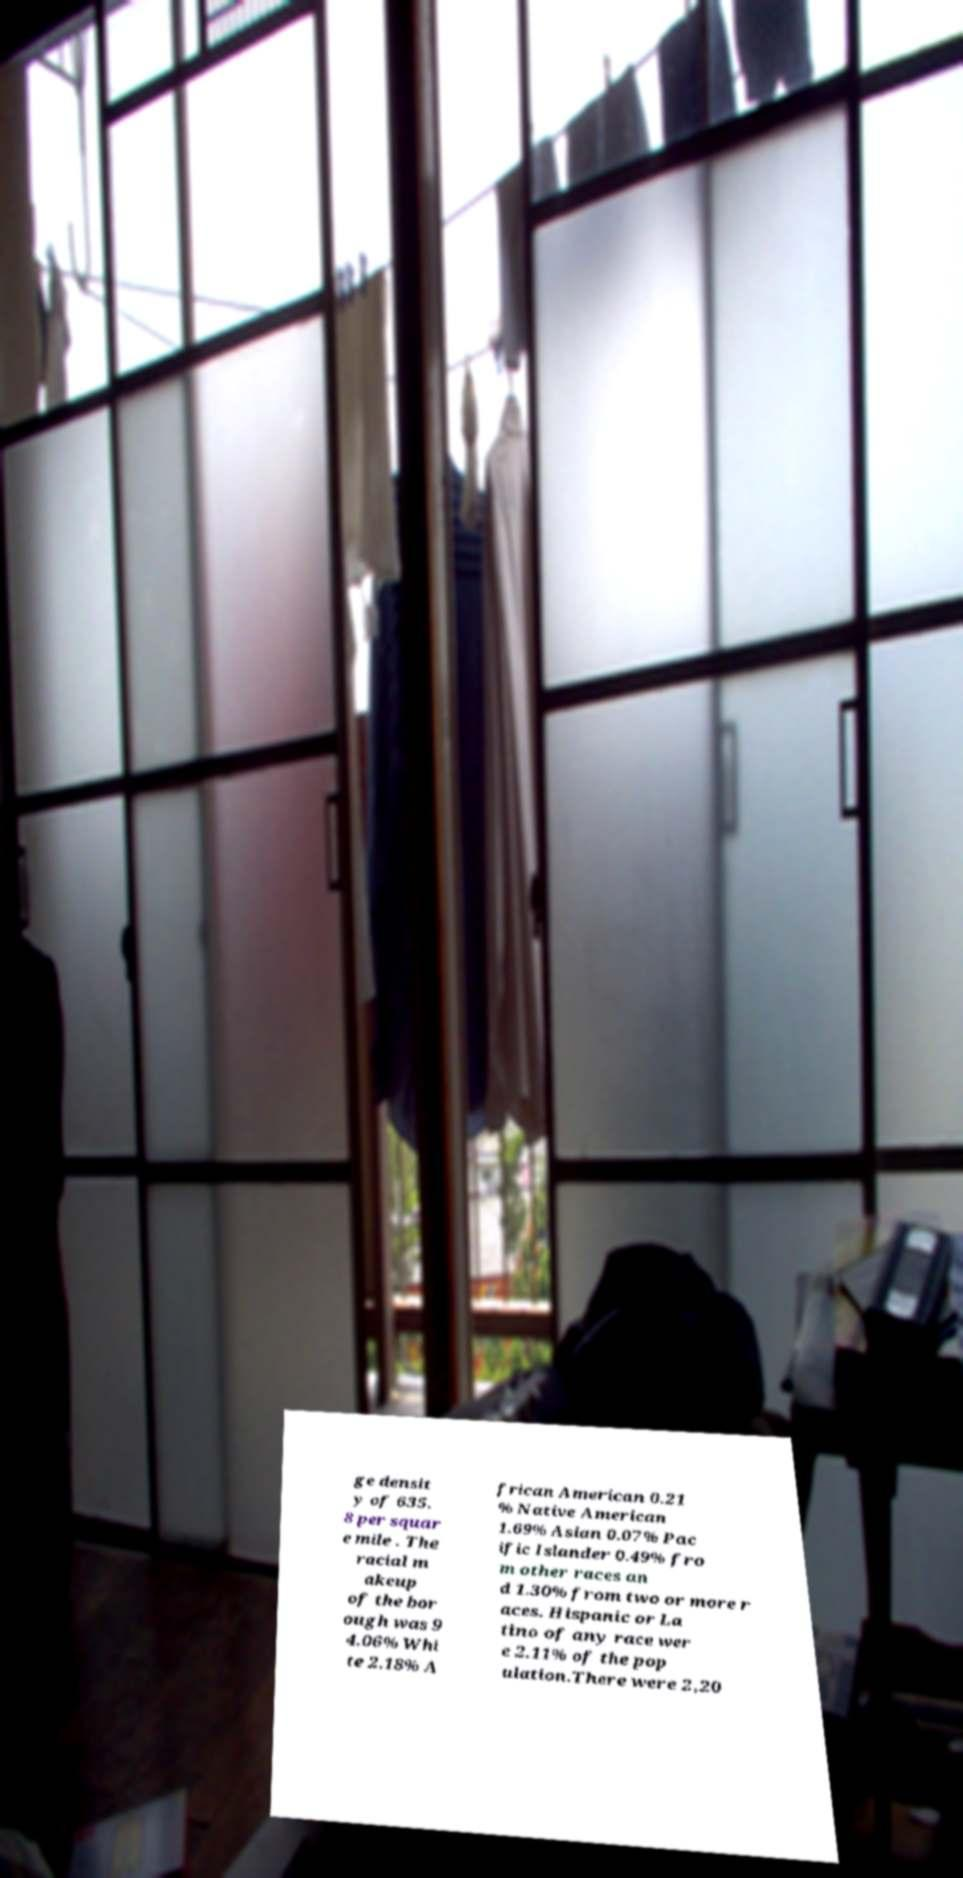Can you accurately transcribe the text from the provided image for me? ge densit y of 635. 8 per squar e mile . The racial m akeup of the bor ough was 9 4.06% Whi te 2.18% A frican American 0.21 % Native American 1.69% Asian 0.07% Pac ific Islander 0.49% fro m other races an d 1.30% from two or more r aces. Hispanic or La tino of any race wer e 2.11% of the pop ulation.There were 2,20 